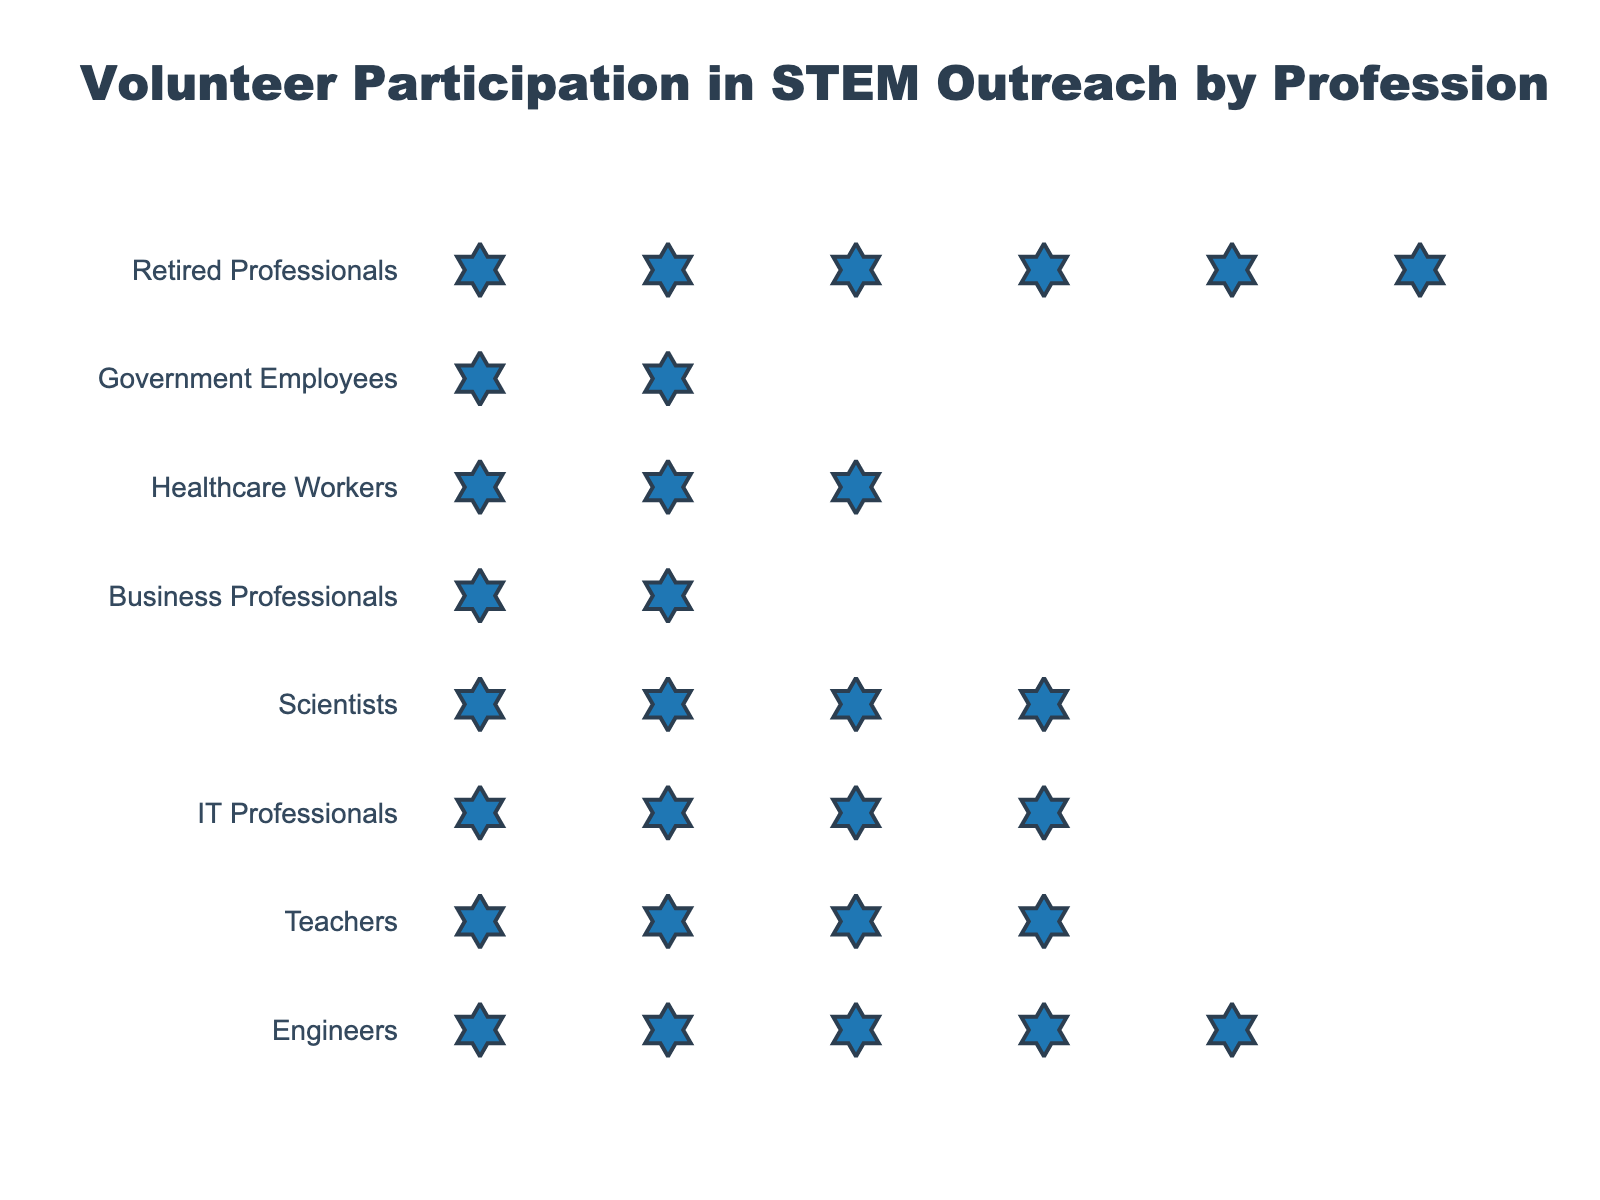what is the title of the figure? The title of the figure is usually displayed prominently at the top. Here, it reads "Volunteer Participation in STEM Outreach by Profession".
Answer: Volunteer Participation in STEM Outreach by Profession which profession has the highest volunteer participation rate? By looking at the figure and comparing the number of icons for each profession, the profession with the most icons represents the highest volunteer participation rate. Here, the highest number of icons is for Retired Professionals.
Answer: Retired Professionals how many volunteers per 100 professionals are there for Engineers? The hover text or icons indicate the volunteers per 100 for each profession. For Engineers, each icon represents 5 volunteers, and by counting the icons, we see Engineers have 5 icons. Multiplying by 5 gives 25.
Answer: 25 how does the participation rate of Teachers compare to Business Professionals? By counting the icons for each, Teachers have 18 volunteers per 100 professionals (3.6 icons), while Business Professionals have 12 (2.4 icons). Teachers have a higher rate.
Answer: Teachers have a higher rate what is the combined volunteer participation rate for Teachers and IT Professionals? To find the combined rate, add the rates for both professions: Teachers (18) + IT Professionals (20) = 38 volunteers per 100 professionals.
Answer: 38 which profession has the lowest volunteer participation rate? The profession with the least number of icons in the plot represents the lowest volunteer participation rate. Government Employees have the fewest icons, indicating the lowest rate.
Answer: Government Employees what is the difference in participation rates between Scientists and Healthcare Workers? Scientists have a rate of 22 volunteers per 100, and Healthcare Workers have 15. The difference is 22 - 15 = 7.
Answer: 7 how many more volunteers per 100 professionals do Engineers have compared to Business Professionals? Engineers have 25 volunteers per 100, and Business Professionals have 12. The difference is 25 - 12 = 13.
Answer: 13 how many icons are used to represent the participation rate of Scientists? Each icon represents 5 volunteers. For Scientists with 22 volunteers per 100 professionals, 22 divided by 5 equals approximately 4.4. Rounded to the nearest whole number, it is 4 icons.
Answer: 4 what is the average volunteer participation rate across all professions? Sum the rates: (25+18+20+22+12+15+10+30) = 152. Divide by the number of professions (8): 152 / 8 = 19.
Answer: 19 